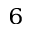<formula> <loc_0><loc_0><loc_500><loc_500>^ { 6 }</formula> 